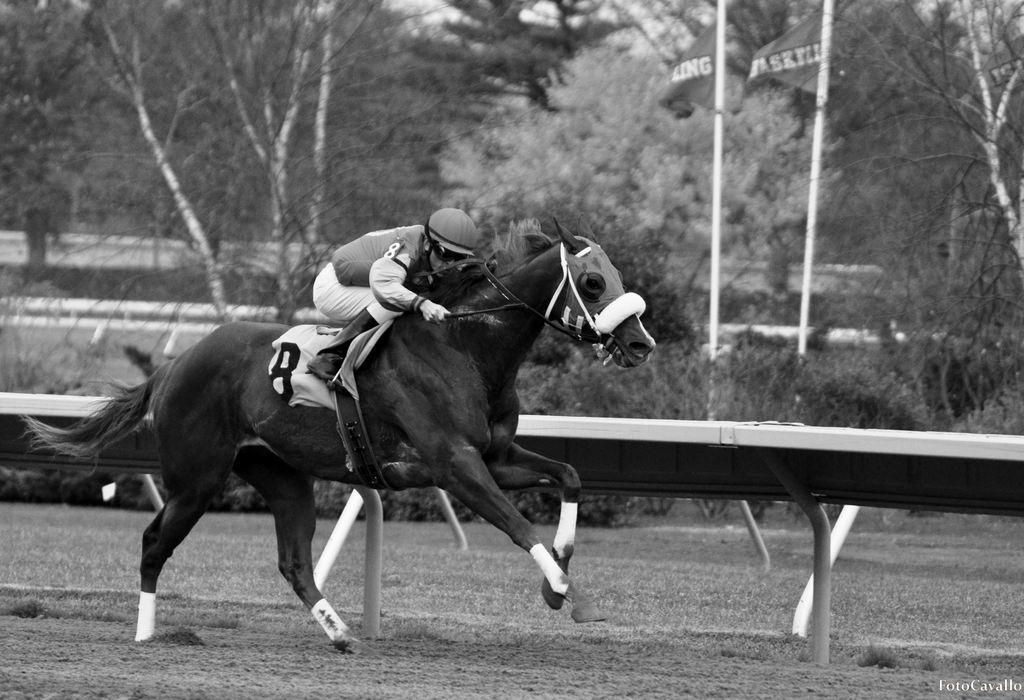Could you give a brief overview of what you see in this image? In this image i can see a person riding the horse at the back ground i can see a bench, a pole, a tree and a flag. 